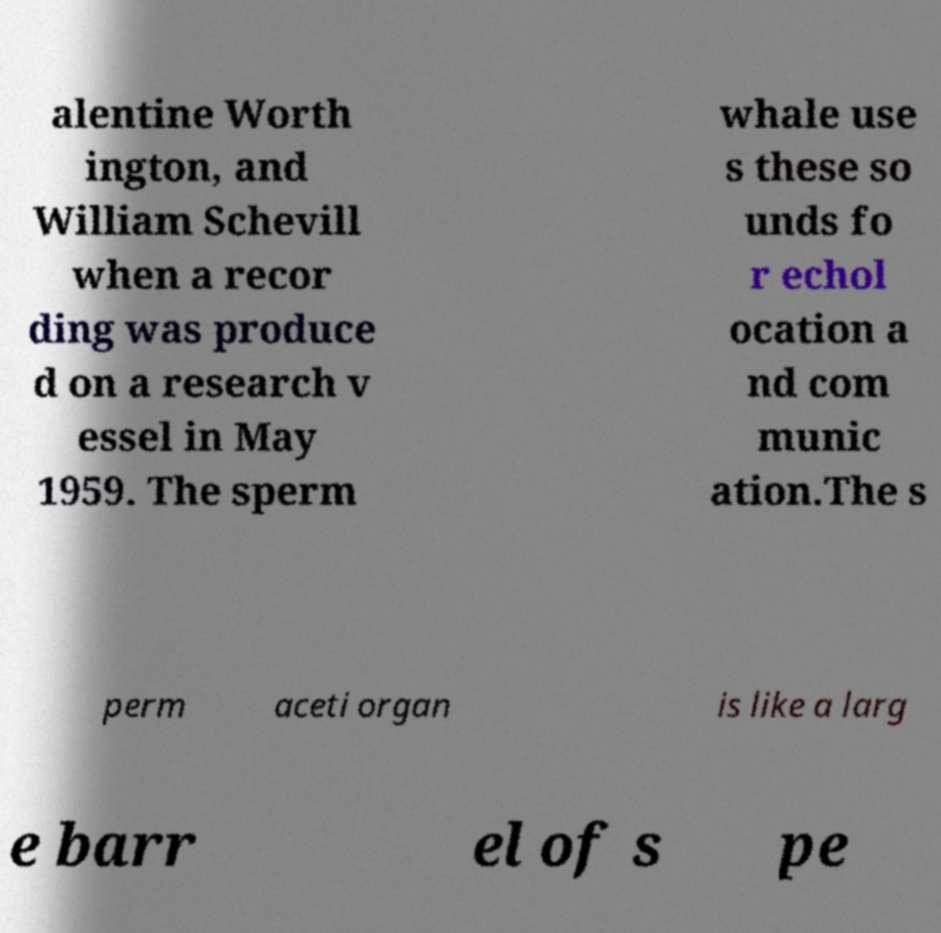Could you extract and type out the text from this image? alentine Worth ington, and William Schevill when a recor ding was produce d on a research v essel in May 1959. The sperm whale use s these so unds fo r echol ocation a nd com munic ation.The s perm aceti organ is like a larg e barr el of s pe 